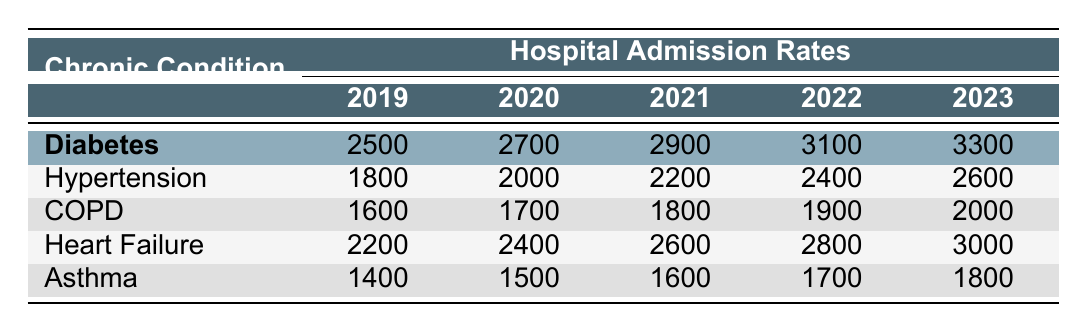What was the hospital admission rate for Diabetes in 2021? The table shows that the admission rate for Diabetes in 2021 is listed under the "2019" to "2023" columns for that condition. The corresponding value for 2021 is 2900.
Answer: 2900 How many hospital admissions were recorded for Hypertension in 2020? The table indicates the number of hospital admissions for Hypertension specifically for the year 2020. The value is 2000.
Answer: 2000 Which chronic condition had the highest number of admissions in 2023? By comparing the admission rates for all conditions listed in the year 2023, Heart Failure has the highest rate of 3000.
Answer: Heart Failure What is the total number of admissions for Asthma over the five years? To find the total, we sum the values of Asthma's admissions from 2019 to 2023: 1400 + 1500 + 1600 + 1700 + 1800 = 10000.
Answer: 10000 Did the admission rate for COPD increase from 2020 to 2021? By looking at the values for COPD in 2020 (1700) and 2021 (1800), we can conclude that the rate increased.
Answer: Yes What was the average admission rate for Heart Failure from 2019 to 2023? The average is calculated by adding all the admissions for Heart Failure across these years and dividing by the number of years: (2200 + 2400 + 2600 + 2800 + 3000) = 15000; 15000 / 5 = 3000.
Answer: 3000 Which condition had the least number of admissions in 2019? We check the admissions from the table for the year 2019 for all chronic conditions: Diabetes (2500), Hypertension (1800), COPD (1600), Heart Failure (2200), Asthma (1400). Asthma had the least with 1400.
Answer: Asthma How many more admissions were there for Diabetes in 2023 compared to 2019? We take the admissions in 2023 (3300) and subtract the admissions in 2019 (2500): 3300 - 2500 = 800.
Answer: 800 Was the increase in admissions for Hypertension from 2022 to 2023 greater than for Asthma from 2022 to 2023? We compare the increases: Hypertension (2600 - 2400 = 200) and Asthma (1800 - 1700 = 100). Since 200 is greater than 100, the statement is true.
Answer: Yes 